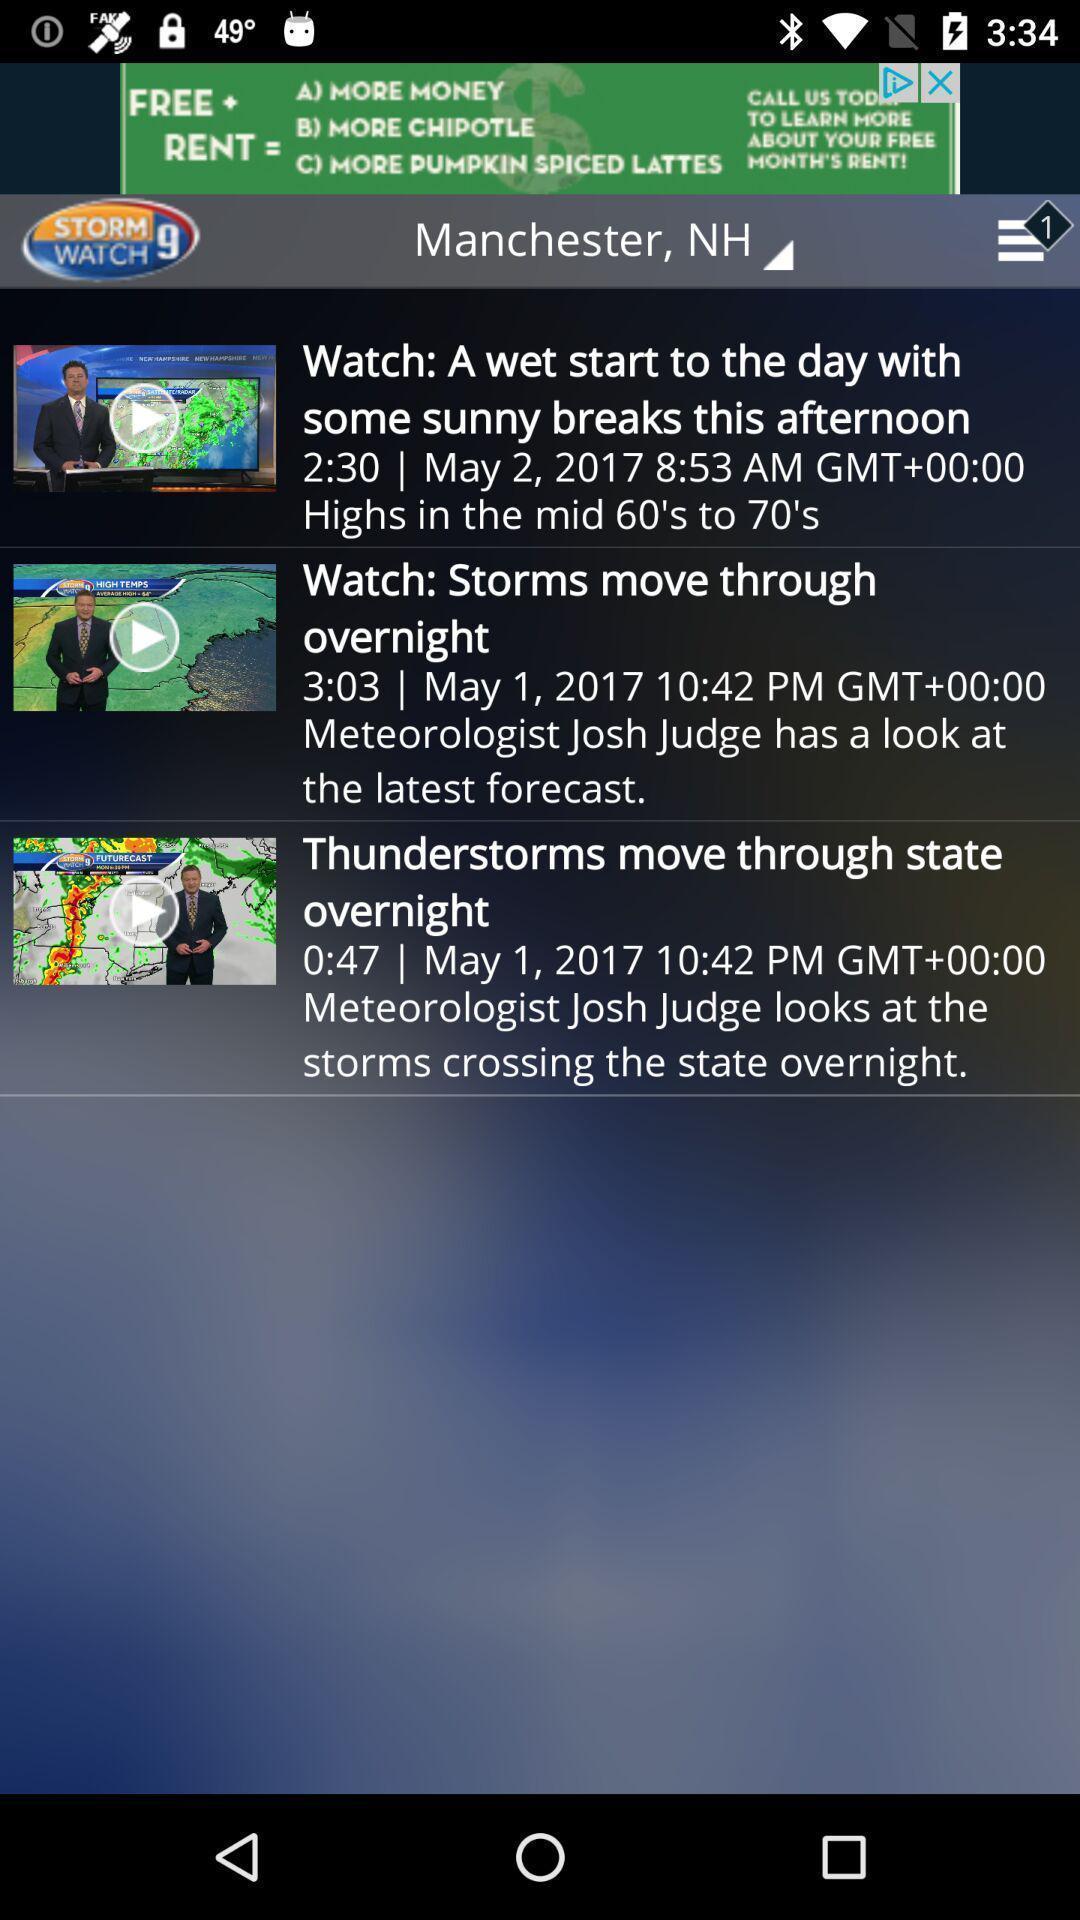What details can you identify in this image? Page displaying with news feed videos regarding weather forecast. 